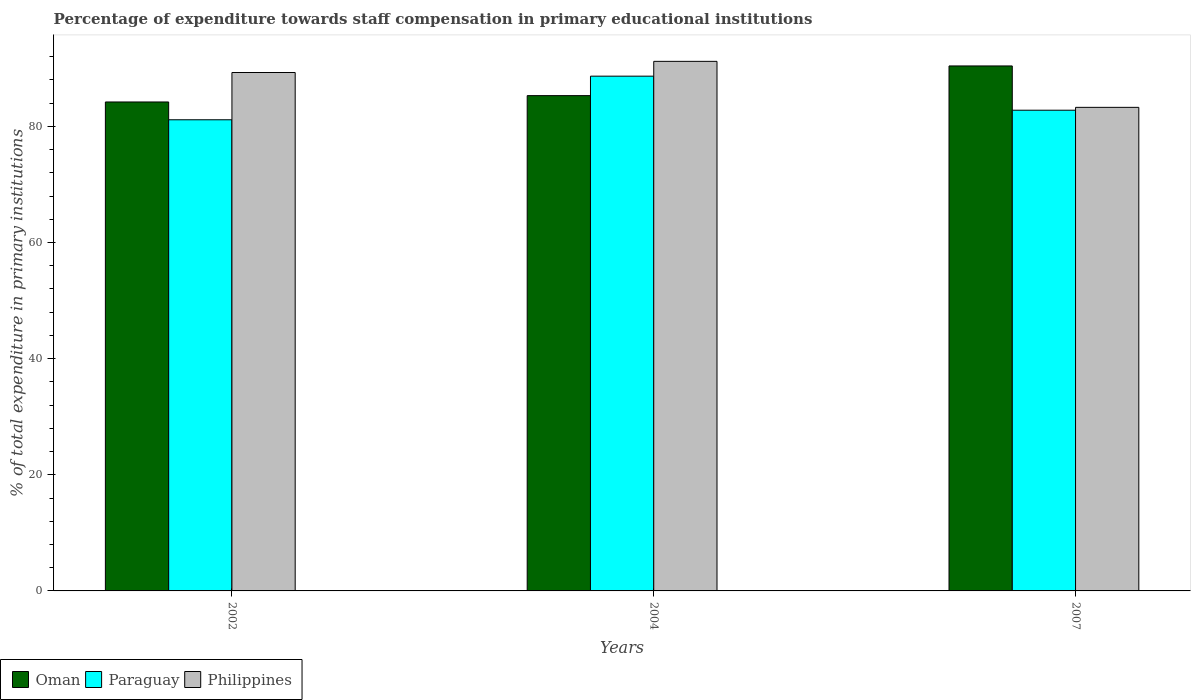How many different coloured bars are there?
Your answer should be compact. 3. How many bars are there on the 2nd tick from the right?
Keep it short and to the point. 3. In how many cases, is the number of bars for a given year not equal to the number of legend labels?
Your answer should be compact. 0. What is the percentage of expenditure towards staff compensation in Philippines in 2004?
Offer a very short reply. 91.2. Across all years, what is the maximum percentage of expenditure towards staff compensation in Philippines?
Your answer should be very brief. 91.2. Across all years, what is the minimum percentage of expenditure towards staff compensation in Oman?
Offer a terse response. 84.21. In which year was the percentage of expenditure towards staff compensation in Philippines maximum?
Provide a succinct answer. 2004. In which year was the percentage of expenditure towards staff compensation in Paraguay minimum?
Your answer should be compact. 2002. What is the total percentage of expenditure towards staff compensation in Oman in the graph?
Provide a short and direct response. 259.92. What is the difference between the percentage of expenditure towards staff compensation in Oman in 2002 and that in 2007?
Make the answer very short. -6.2. What is the difference between the percentage of expenditure towards staff compensation in Philippines in 2007 and the percentage of expenditure towards staff compensation in Paraguay in 2004?
Give a very brief answer. -5.37. What is the average percentage of expenditure towards staff compensation in Oman per year?
Your answer should be compact. 86.64. In the year 2007, what is the difference between the percentage of expenditure towards staff compensation in Paraguay and percentage of expenditure towards staff compensation in Oman?
Provide a succinct answer. -7.62. What is the ratio of the percentage of expenditure towards staff compensation in Philippines in 2002 to that in 2007?
Offer a terse response. 1.07. Is the difference between the percentage of expenditure towards staff compensation in Paraguay in 2002 and 2007 greater than the difference between the percentage of expenditure towards staff compensation in Oman in 2002 and 2007?
Make the answer very short. Yes. What is the difference between the highest and the second highest percentage of expenditure towards staff compensation in Philippines?
Ensure brevity in your answer.  1.92. What is the difference between the highest and the lowest percentage of expenditure towards staff compensation in Paraguay?
Provide a succinct answer. 7.51. Is the sum of the percentage of expenditure towards staff compensation in Paraguay in 2002 and 2004 greater than the maximum percentage of expenditure towards staff compensation in Philippines across all years?
Make the answer very short. Yes. What does the 2nd bar from the left in 2004 represents?
Keep it short and to the point. Paraguay. What does the 2nd bar from the right in 2007 represents?
Your answer should be compact. Paraguay. Are the values on the major ticks of Y-axis written in scientific E-notation?
Keep it short and to the point. No. Does the graph contain any zero values?
Make the answer very short. No. How many legend labels are there?
Offer a terse response. 3. How are the legend labels stacked?
Offer a very short reply. Horizontal. What is the title of the graph?
Keep it short and to the point. Percentage of expenditure towards staff compensation in primary educational institutions. What is the label or title of the Y-axis?
Offer a very short reply. % of total expenditure in primary institutions. What is the % of total expenditure in primary institutions of Oman in 2002?
Provide a short and direct response. 84.21. What is the % of total expenditure in primary institutions in Paraguay in 2002?
Ensure brevity in your answer.  81.14. What is the % of total expenditure in primary institutions in Philippines in 2002?
Your response must be concise. 89.28. What is the % of total expenditure in primary institutions of Oman in 2004?
Your answer should be very brief. 85.3. What is the % of total expenditure in primary institutions of Paraguay in 2004?
Provide a succinct answer. 88.65. What is the % of total expenditure in primary institutions in Philippines in 2004?
Keep it short and to the point. 91.2. What is the % of total expenditure in primary institutions of Oman in 2007?
Give a very brief answer. 90.41. What is the % of total expenditure in primary institutions in Paraguay in 2007?
Your answer should be very brief. 82.79. What is the % of total expenditure in primary institutions of Philippines in 2007?
Keep it short and to the point. 83.28. Across all years, what is the maximum % of total expenditure in primary institutions in Oman?
Offer a very short reply. 90.41. Across all years, what is the maximum % of total expenditure in primary institutions of Paraguay?
Give a very brief answer. 88.65. Across all years, what is the maximum % of total expenditure in primary institutions in Philippines?
Your answer should be compact. 91.2. Across all years, what is the minimum % of total expenditure in primary institutions in Oman?
Your response must be concise. 84.21. Across all years, what is the minimum % of total expenditure in primary institutions of Paraguay?
Your response must be concise. 81.14. Across all years, what is the minimum % of total expenditure in primary institutions in Philippines?
Your answer should be compact. 83.28. What is the total % of total expenditure in primary institutions of Oman in the graph?
Your response must be concise. 259.92. What is the total % of total expenditure in primary institutions in Paraguay in the graph?
Keep it short and to the point. 252.58. What is the total % of total expenditure in primary institutions of Philippines in the graph?
Your answer should be compact. 263.77. What is the difference between the % of total expenditure in primary institutions of Oman in 2002 and that in 2004?
Make the answer very short. -1.09. What is the difference between the % of total expenditure in primary institutions in Paraguay in 2002 and that in 2004?
Provide a succinct answer. -7.51. What is the difference between the % of total expenditure in primary institutions in Philippines in 2002 and that in 2004?
Ensure brevity in your answer.  -1.92. What is the difference between the % of total expenditure in primary institutions in Oman in 2002 and that in 2007?
Your answer should be very brief. -6.2. What is the difference between the % of total expenditure in primary institutions in Paraguay in 2002 and that in 2007?
Give a very brief answer. -1.65. What is the difference between the % of total expenditure in primary institutions of Philippines in 2002 and that in 2007?
Make the answer very short. 6. What is the difference between the % of total expenditure in primary institutions in Oman in 2004 and that in 2007?
Provide a short and direct response. -5.11. What is the difference between the % of total expenditure in primary institutions of Paraguay in 2004 and that in 2007?
Give a very brief answer. 5.86. What is the difference between the % of total expenditure in primary institutions in Philippines in 2004 and that in 2007?
Ensure brevity in your answer.  7.92. What is the difference between the % of total expenditure in primary institutions in Oman in 2002 and the % of total expenditure in primary institutions in Paraguay in 2004?
Provide a succinct answer. -4.44. What is the difference between the % of total expenditure in primary institutions in Oman in 2002 and the % of total expenditure in primary institutions in Philippines in 2004?
Make the answer very short. -7. What is the difference between the % of total expenditure in primary institutions in Paraguay in 2002 and the % of total expenditure in primary institutions in Philippines in 2004?
Offer a very short reply. -10.06. What is the difference between the % of total expenditure in primary institutions of Oman in 2002 and the % of total expenditure in primary institutions of Paraguay in 2007?
Provide a short and direct response. 1.42. What is the difference between the % of total expenditure in primary institutions of Oman in 2002 and the % of total expenditure in primary institutions of Philippines in 2007?
Provide a succinct answer. 0.93. What is the difference between the % of total expenditure in primary institutions in Paraguay in 2002 and the % of total expenditure in primary institutions in Philippines in 2007?
Provide a short and direct response. -2.14. What is the difference between the % of total expenditure in primary institutions in Oman in 2004 and the % of total expenditure in primary institutions in Paraguay in 2007?
Offer a very short reply. 2.51. What is the difference between the % of total expenditure in primary institutions in Oman in 2004 and the % of total expenditure in primary institutions in Philippines in 2007?
Make the answer very short. 2.02. What is the difference between the % of total expenditure in primary institutions in Paraguay in 2004 and the % of total expenditure in primary institutions in Philippines in 2007?
Offer a very short reply. 5.37. What is the average % of total expenditure in primary institutions of Oman per year?
Your answer should be very brief. 86.64. What is the average % of total expenditure in primary institutions in Paraguay per year?
Give a very brief answer. 84.19. What is the average % of total expenditure in primary institutions in Philippines per year?
Keep it short and to the point. 87.92. In the year 2002, what is the difference between the % of total expenditure in primary institutions of Oman and % of total expenditure in primary institutions of Paraguay?
Your answer should be very brief. 3.07. In the year 2002, what is the difference between the % of total expenditure in primary institutions in Oman and % of total expenditure in primary institutions in Philippines?
Provide a succinct answer. -5.08. In the year 2002, what is the difference between the % of total expenditure in primary institutions in Paraguay and % of total expenditure in primary institutions in Philippines?
Provide a short and direct response. -8.14. In the year 2004, what is the difference between the % of total expenditure in primary institutions of Oman and % of total expenditure in primary institutions of Paraguay?
Offer a terse response. -3.35. In the year 2004, what is the difference between the % of total expenditure in primary institutions of Oman and % of total expenditure in primary institutions of Philippines?
Give a very brief answer. -5.9. In the year 2004, what is the difference between the % of total expenditure in primary institutions of Paraguay and % of total expenditure in primary institutions of Philippines?
Give a very brief answer. -2.55. In the year 2007, what is the difference between the % of total expenditure in primary institutions in Oman and % of total expenditure in primary institutions in Paraguay?
Your response must be concise. 7.62. In the year 2007, what is the difference between the % of total expenditure in primary institutions in Oman and % of total expenditure in primary institutions in Philippines?
Give a very brief answer. 7.13. In the year 2007, what is the difference between the % of total expenditure in primary institutions of Paraguay and % of total expenditure in primary institutions of Philippines?
Offer a very short reply. -0.49. What is the ratio of the % of total expenditure in primary institutions of Oman in 2002 to that in 2004?
Make the answer very short. 0.99. What is the ratio of the % of total expenditure in primary institutions in Paraguay in 2002 to that in 2004?
Give a very brief answer. 0.92. What is the ratio of the % of total expenditure in primary institutions of Philippines in 2002 to that in 2004?
Keep it short and to the point. 0.98. What is the ratio of the % of total expenditure in primary institutions in Oman in 2002 to that in 2007?
Provide a succinct answer. 0.93. What is the ratio of the % of total expenditure in primary institutions in Paraguay in 2002 to that in 2007?
Offer a very short reply. 0.98. What is the ratio of the % of total expenditure in primary institutions of Philippines in 2002 to that in 2007?
Offer a terse response. 1.07. What is the ratio of the % of total expenditure in primary institutions in Oman in 2004 to that in 2007?
Offer a very short reply. 0.94. What is the ratio of the % of total expenditure in primary institutions in Paraguay in 2004 to that in 2007?
Your answer should be compact. 1.07. What is the ratio of the % of total expenditure in primary institutions in Philippines in 2004 to that in 2007?
Offer a terse response. 1.1. What is the difference between the highest and the second highest % of total expenditure in primary institutions in Oman?
Offer a terse response. 5.11. What is the difference between the highest and the second highest % of total expenditure in primary institutions of Paraguay?
Offer a terse response. 5.86. What is the difference between the highest and the second highest % of total expenditure in primary institutions of Philippines?
Your answer should be compact. 1.92. What is the difference between the highest and the lowest % of total expenditure in primary institutions of Oman?
Provide a succinct answer. 6.2. What is the difference between the highest and the lowest % of total expenditure in primary institutions in Paraguay?
Give a very brief answer. 7.51. What is the difference between the highest and the lowest % of total expenditure in primary institutions of Philippines?
Offer a very short reply. 7.92. 